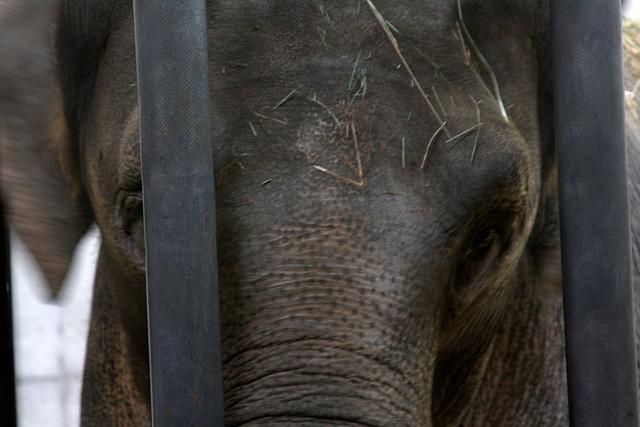How many animals are in the picture?
Give a very brief answer. 1. 